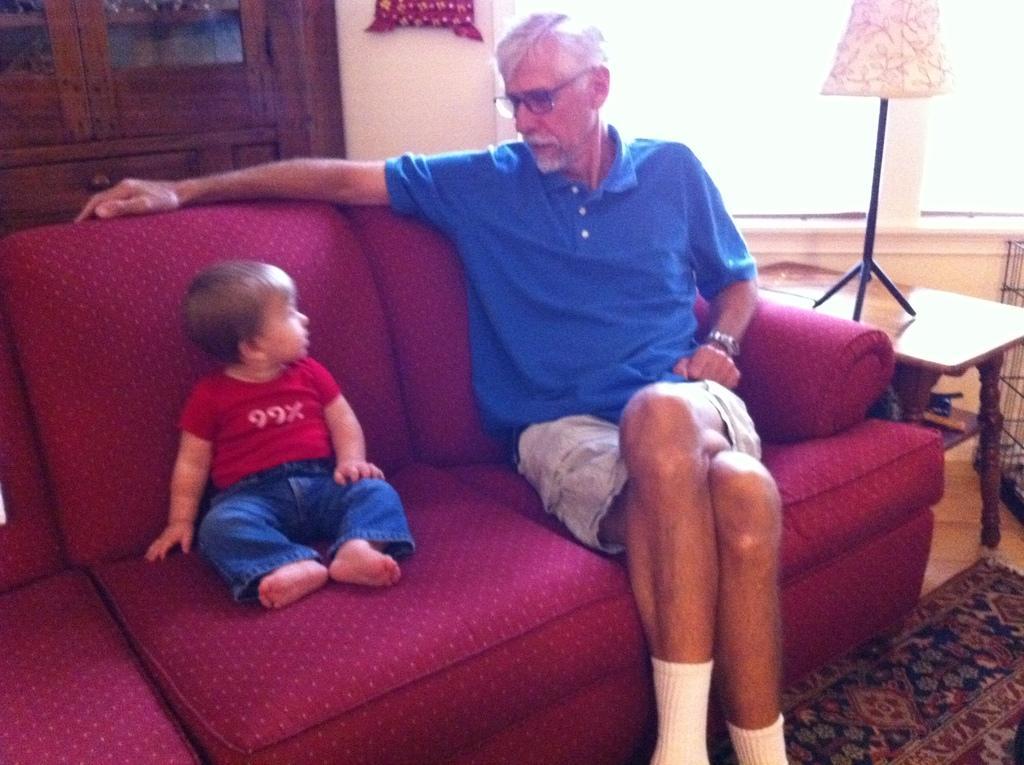Can you describe this image briefly? In this picture i could see an old man and kid sitting on the red color sofa in the background i could see a wooden cabinet and windows and lamp holder in the right side of the picture. 